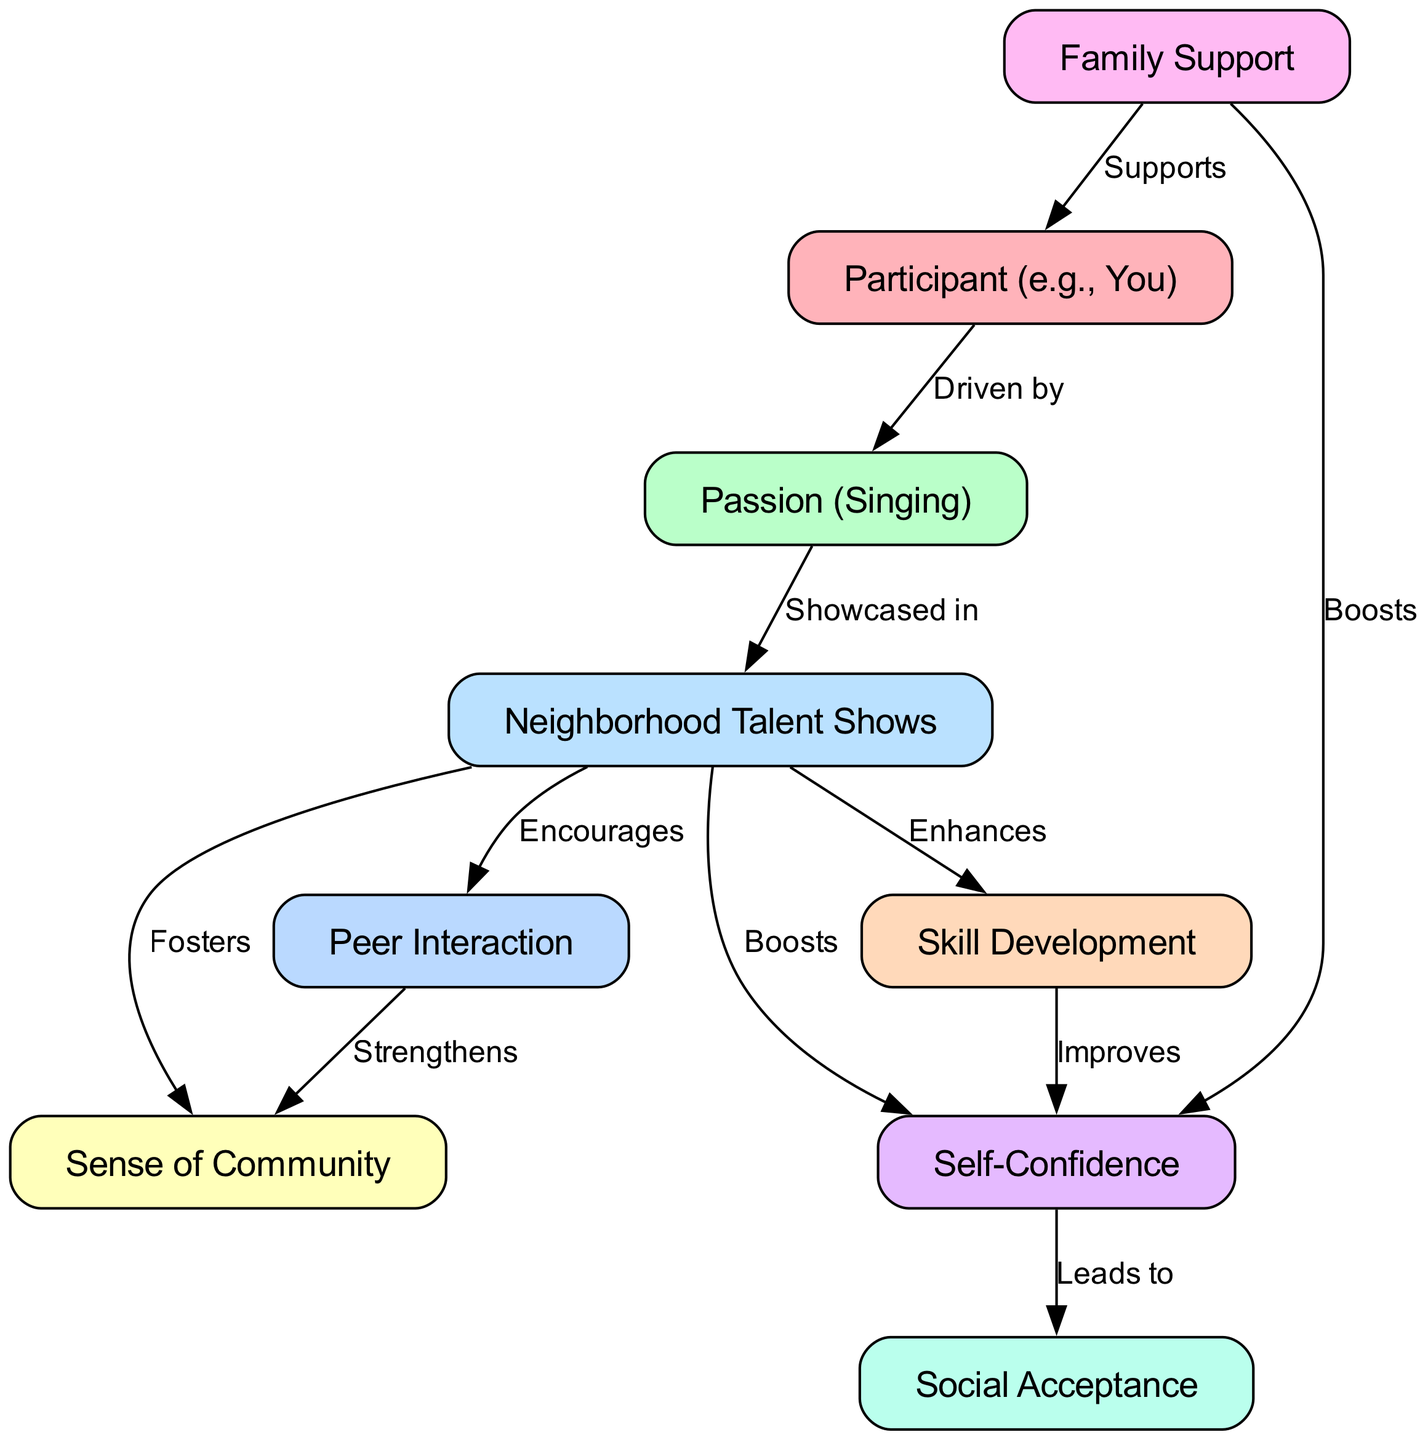What is the main passion of the participant? The participant is primarily involved in singing, as indicated directly by the connection labeled "Driven by" between the participant node and the passion node.
Answer: Singing How many nodes are present in the diagram? By counting each distinct entity or concept, we find there are 9 nodes: Participant, Passion, Events, Community, Skills, Confidence, Peer Interaction, Support, and Acceptance.
Answer: 9 What does the event of neighborhood talent shows enhance? The label "Enhances" directly connects the events node to the skills node, indicating that the talent shows serve to improve skills.
Answer: Skills What is the outcome of increased confidence as per the diagram? The diagram shows a connection from the confidence node to the acceptance node, labeled "Leads to," indicating that increased confidence results in social acceptance.
Answer: Social Acceptance Which node supports the participant directly? The diagram indicates a direct connection labeled "Supports" between the support node and the participant node, suggesting that family support is a contributor to the participant's experience.
Answer: Family Support How does peer interaction influence the sense of community? According to the diagram, there is an edge labeled "Strengthens" that links the peer interaction node to the community node, illustrating how interactions among peers enhance the sense of community.
Answer: Strengthens What effect do neighborhood talent shows have on self-confidence? The edge labeled "Boosts" shows a direct relationship between the events node and the confidence node, highlighting that participating in talent shows increases self-confidence.
Answer: Boosts What role does family support play in boosting confidence? The diagram illustrates a direct edge labeled "Boosts" from the support node to the confidence node, conveying that family support actively contributes to enhancing confidence.
Answer: Boosts What does participation in neighborhood talent shows lead to in terms of community? The label "Fosters" on the edge from events to community shows that neighborhood talent shows contribute to creating a sense of community among participants and attendees.
Answer: Fosters 